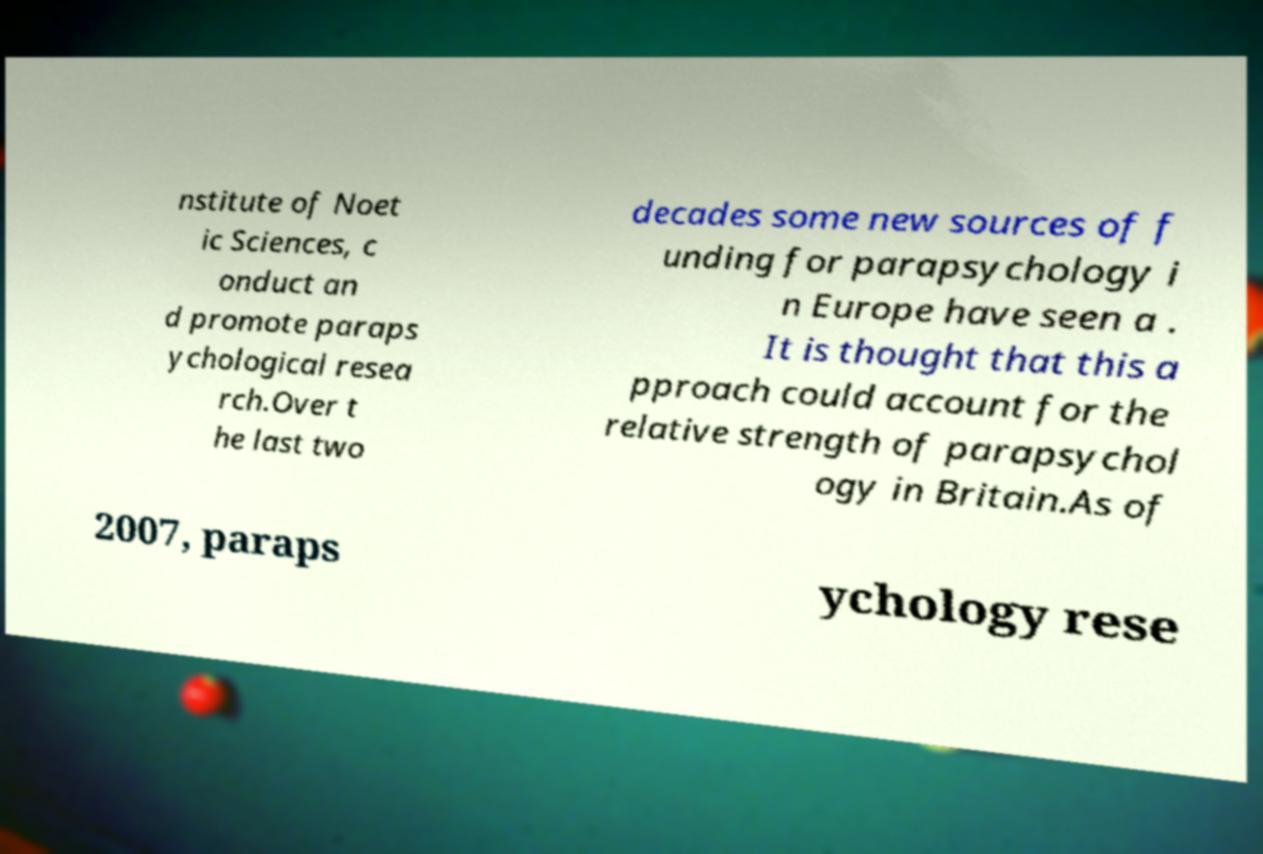Could you assist in decoding the text presented in this image and type it out clearly? nstitute of Noet ic Sciences, c onduct an d promote paraps ychological resea rch.Over t he last two decades some new sources of f unding for parapsychology i n Europe have seen a . It is thought that this a pproach could account for the relative strength of parapsychol ogy in Britain.As of 2007, paraps ychology rese 